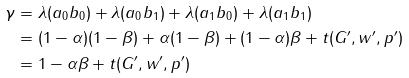Convert formula to latex. <formula><loc_0><loc_0><loc_500><loc_500>\gamma & = \lambda ( a _ { 0 } b _ { 0 } ) + \lambda ( a _ { 0 } b _ { 1 } ) + \lambda ( a _ { 1 } b _ { 0 } ) + \lambda ( a _ { 1 } b _ { 1 } ) \\ & = ( 1 - \alpha ) ( 1 - \beta ) + \alpha ( 1 - \beta ) + ( 1 - \alpha ) \beta + t ( G ^ { \prime } , w ^ { \prime } , p ^ { \prime } ) \\ & = 1 - \alpha \beta + t ( G ^ { \prime } , w ^ { \prime } , p ^ { \prime } )</formula> 